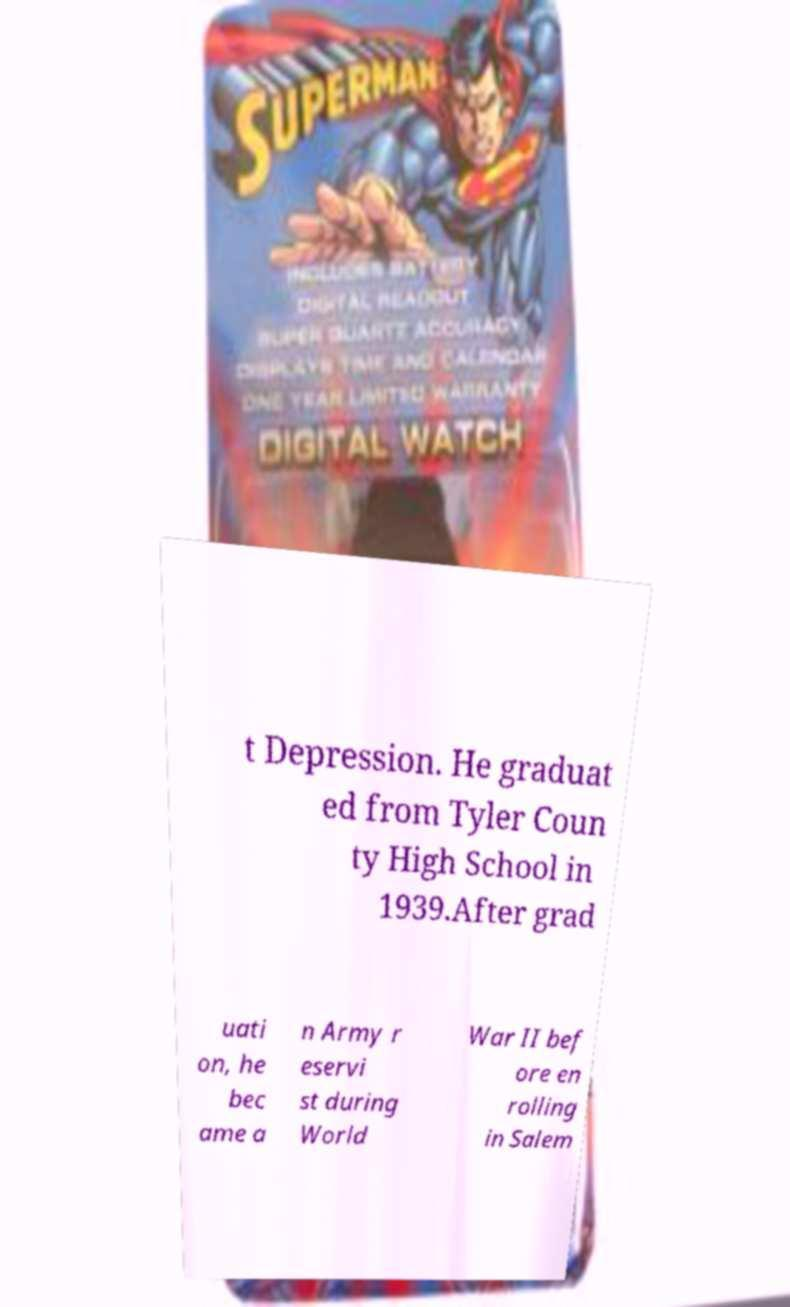Can you read and provide the text displayed in the image?This photo seems to have some interesting text. Can you extract and type it out for me? t Depression. He graduat ed from Tyler Coun ty High School in 1939.After grad uati on, he bec ame a n Army r eservi st during World War II bef ore en rolling in Salem 